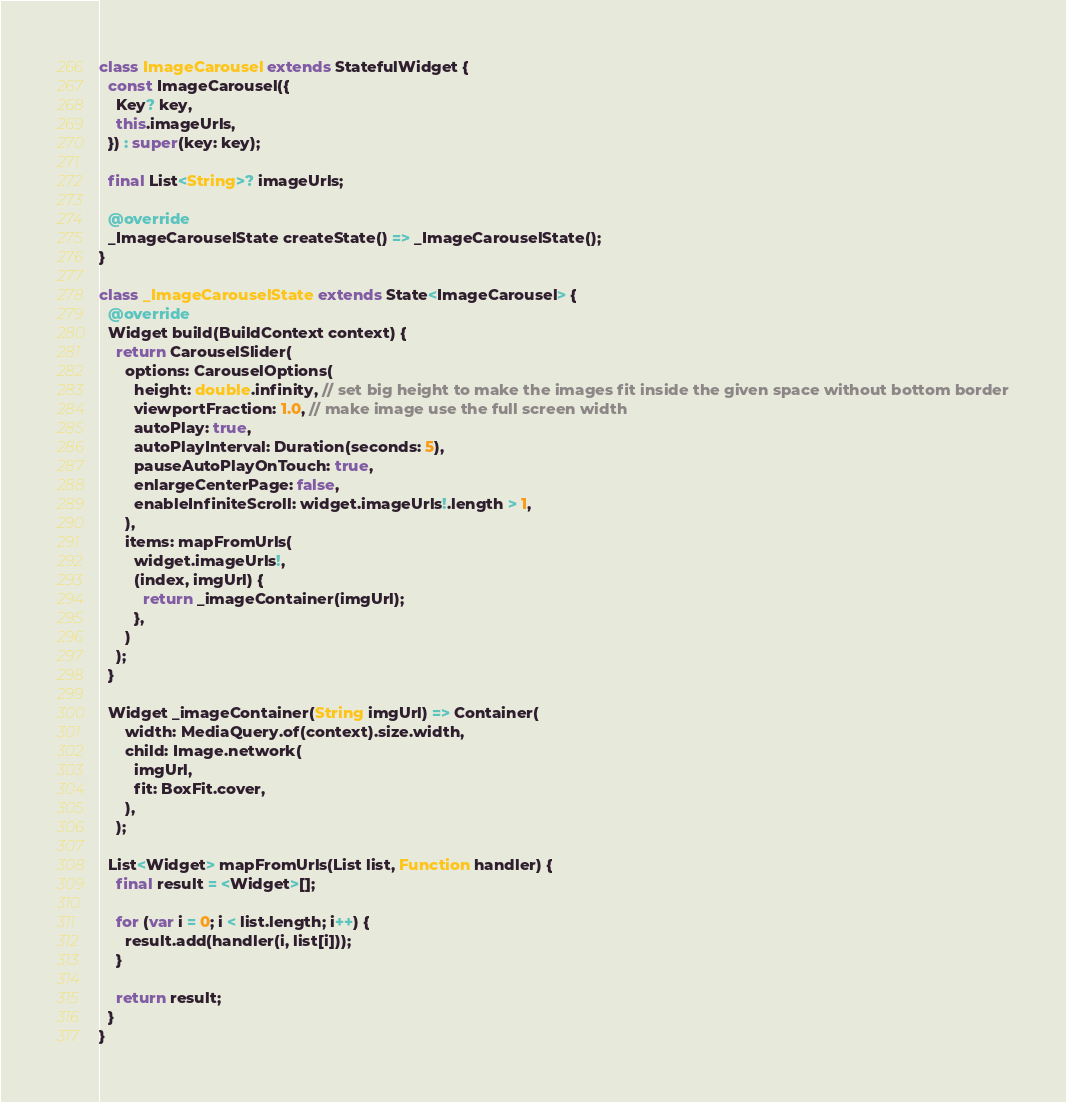<code> <loc_0><loc_0><loc_500><loc_500><_Dart_>class ImageCarousel extends StatefulWidget {
  const ImageCarousel({
    Key? key,
    this.imageUrls,
  }) : super(key: key);

  final List<String>? imageUrls;

  @override
  _ImageCarouselState createState() => _ImageCarouselState();
}

class _ImageCarouselState extends State<ImageCarousel> {
  @override
  Widget build(BuildContext context) {
    return CarouselSlider(
      options: CarouselOptions(
        height: double.infinity, // set big height to make the images fit inside the given space without bottom border
        viewportFraction: 1.0, // make image use the full screen width
        autoPlay: true,
        autoPlayInterval: Duration(seconds: 5),
        pauseAutoPlayOnTouch: true,
        enlargeCenterPage: false,
        enableInfiniteScroll: widget.imageUrls!.length > 1,
      ),
      items: mapFromUrls(
        widget.imageUrls!, 
        (index, imgUrl) {
          return _imageContainer(imgUrl);
        },
      )
    );
  }

  Widget _imageContainer(String imgUrl) => Container(
      width: MediaQuery.of(context).size.width,
      child: Image.network(
        imgUrl,
        fit: BoxFit.cover,
      ),
    );

  List<Widget> mapFromUrls(List list, Function handler) {
    final result = <Widget>[];

    for (var i = 0; i < list.length; i++) {
      result.add(handler(i, list[i]));
    }

    return result;
  }
}</code> 